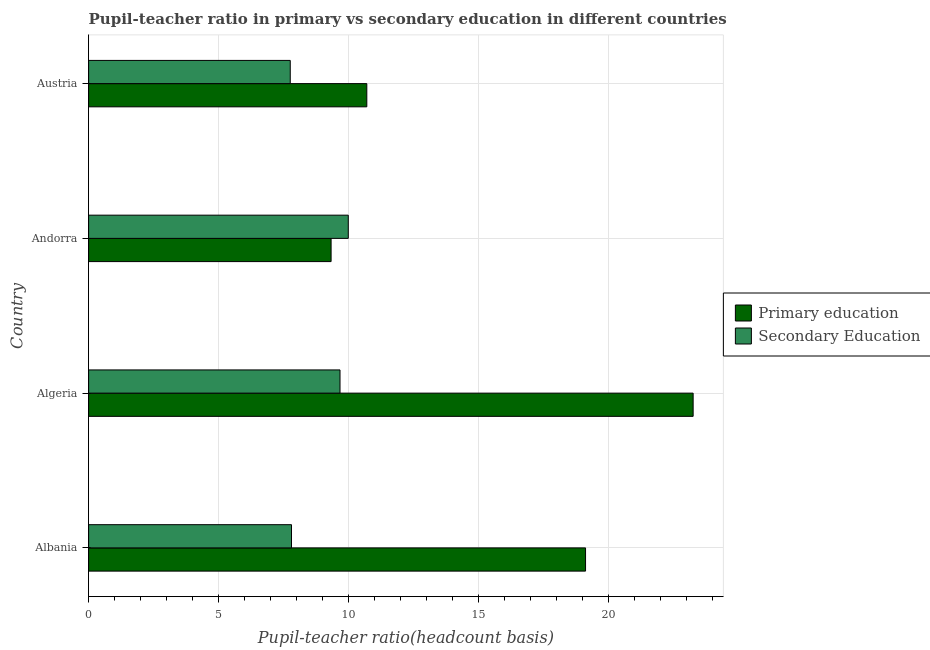How many different coloured bars are there?
Your answer should be very brief. 2. Are the number of bars on each tick of the Y-axis equal?
Keep it short and to the point. Yes. How many bars are there on the 3rd tick from the top?
Your answer should be compact. 2. How many bars are there on the 1st tick from the bottom?
Your answer should be very brief. 2. What is the label of the 3rd group of bars from the top?
Keep it short and to the point. Algeria. What is the pupil teacher ratio on secondary education in Andorra?
Give a very brief answer. 9.99. Across all countries, what is the maximum pupil teacher ratio on secondary education?
Your response must be concise. 9.99. Across all countries, what is the minimum pupil teacher ratio on secondary education?
Keep it short and to the point. 7.76. In which country was the pupil teacher ratio on secondary education maximum?
Ensure brevity in your answer.  Andorra. What is the total pupil-teacher ratio in primary education in the graph?
Offer a terse response. 62.42. What is the difference between the pupil-teacher ratio in primary education in Andorra and that in Austria?
Provide a short and direct response. -1.37. What is the difference between the pupil-teacher ratio in primary education in Andorra and the pupil teacher ratio on secondary education in Algeria?
Your response must be concise. -0.34. What is the average pupil-teacher ratio in primary education per country?
Make the answer very short. 15.6. What is the difference between the pupil teacher ratio on secondary education and pupil-teacher ratio in primary education in Andorra?
Keep it short and to the point. 0.66. What is the ratio of the pupil-teacher ratio in primary education in Albania to that in Algeria?
Give a very brief answer. 0.82. Is the pupil-teacher ratio in primary education in Algeria less than that in Austria?
Make the answer very short. No. What is the difference between the highest and the second highest pupil-teacher ratio in primary education?
Provide a succinct answer. 4.14. What is the difference between the highest and the lowest pupil teacher ratio on secondary education?
Offer a very short reply. 2.23. What does the 2nd bar from the bottom in Austria represents?
Offer a very short reply. Secondary Education. How many bars are there?
Ensure brevity in your answer.  8. Are all the bars in the graph horizontal?
Offer a terse response. Yes. How many countries are there in the graph?
Make the answer very short. 4. What is the difference between two consecutive major ticks on the X-axis?
Offer a terse response. 5. Are the values on the major ticks of X-axis written in scientific E-notation?
Your answer should be very brief. No. Does the graph contain grids?
Your answer should be compact. Yes. Where does the legend appear in the graph?
Your response must be concise. Center right. How are the legend labels stacked?
Give a very brief answer. Vertical. What is the title of the graph?
Offer a terse response. Pupil-teacher ratio in primary vs secondary education in different countries. Does "Male population" appear as one of the legend labels in the graph?
Offer a very short reply. No. What is the label or title of the X-axis?
Ensure brevity in your answer.  Pupil-teacher ratio(headcount basis). What is the Pupil-teacher ratio(headcount basis) in Primary education in Albania?
Make the answer very short. 19.12. What is the Pupil-teacher ratio(headcount basis) in Secondary Education in Albania?
Make the answer very short. 7.81. What is the Pupil-teacher ratio(headcount basis) of Primary education in Algeria?
Make the answer very short. 23.26. What is the Pupil-teacher ratio(headcount basis) in Secondary Education in Algeria?
Offer a very short reply. 9.67. What is the Pupil-teacher ratio(headcount basis) of Primary education in Andorra?
Provide a short and direct response. 9.33. What is the Pupil-teacher ratio(headcount basis) of Secondary Education in Andorra?
Your response must be concise. 9.99. What is the Pupil-teacher ratio(headcount basis) of Primary education in Austria?
Keep it short and to the point. 10.7. What is the Pupil-teacher ratio(headcount basis) in Secondary Education in Austria?
Offer a terse response. 7.76. Across all countries, what is the maximum Pupil-teacher ratio(headcount basis) in Primary education?
Keep it short and to the point. 23.26. Across all countries, what is the maximum Pupil-teacher ratio(headcount basis) in Secondary Education?
Ensure brevity in your answer.  9.99. Across all countries, what is the minimum Pupil-teacher ratio(headcount basis) of Primary education?
Your answer should be compact. 9.33. Across all countries, what is the minimum Pupil-teacher ratio(headcount basis) in Secondary Education?
Give a very brief answer. 7.76. What is the total Pupil-teacher ratio(headcount basis) of Primary education in the graph?
Offer a very short reply. 62.42. What is the total Pupil-teacher ratio(headcount basis) of Secondary Education in the graph?
Offer a terse response. 35.23. What is the difference between the Pupil-teacher ratio(headcount basis) of Primary education in Albania and that in Algeria?
Keep it short and to the point. -4.14. What is the difference between the Pupil-teacher ratio(headcount basis) in Secondary Education in Albania and that in Algeria?
Your answer should be very brief. -1.87. What is the difference between the Pupil-teacher ratio(headcount basis) in Primary education in Albania and that in Andorra?
Offer a terse response. 9.79. What is the difference between the Pupil-teacher ratio(headcount basis) of Secondary Education in Albania and that in Andorra?
Ensure brevity in your answer.  -2.19. What is the difference between the Pupil-teacher ratio(headcount basis) in Primary education in Albania and that in Austria?
Provide a short and direct response. 8.42. What is the difference between the Pupil-teacher ratio(headcount basis) of Secondary Education in Albania and that in Austria?
Your answer should be compact. 0.05. What is the difference between the Pupil-teacher ratio(headcount basis) in Primary education in Algeria and that in Andorra?
Make the answer very short. 13.93. What is the difference between the Pupil-teacher ratio(headcount basis) of Secondary Education in Algeria and that in Andorra?
Give a very brief answer. -0.32. What is the difference between the Pupil-teacher ratio(headcount basis) of Primary education in Algeria and that in Austria?
Your answer should be compact. 12.56. What is the difference between the Pupil-teacher ratio(headcount basis) of Secondary Education in Algeria and that in Austria?
Your answer should be very brief. 1.92. What is the difference between the Pupil-teacher ratio(headcount basis) of Primary education in Andorra and that in Austria?
Your response must be concise. -1.37. What is the difference between the Pupil-teacher ratio(headcount basis) of Secondary Education in Andorra and that in Austria?
Provide a succinct answer. 2.23. What is the difference between the Pupil-teacher ratio(headcount basis) of Primary education in Albania and the Pupil-teacher ratio(headcount basis) of Secondary Education in Algeria?
Provide a succinct answer. 9.45. What is the difference between the Pupil-teacher ratio(headcount basis) in Primary education in Albania and the Pupil-teacher ratio(headcount basis) in Secondary Education in Andorra?
Offer a terse response. 9.13. What is the difference between the Pupil-teacher ratio(headcount basis) in Primary education in Albania and the Pupil-teacher ratio(headcount basis) in Secondary Education in Austria?
Your answer should be very brief. 11.36. What is the difference between the Pupil-teacher ratio(headcount basis) of Primary education in Algeria and the Pupil-teacher ratio(headcount basis) of Secondary Education in Andorra?
Ensure brevity in your answer.  13.27. What is the difference between the Pupil-teacher ratio(headcount basis) in Primary education in Algeria and the Pupil-teacher ratio(headcount basis) in Secondary Education in Austria?
Give a very brief answer. 15.5. What is the difference between the Pupil-teacher ratio(headcount basis) in Primary education in Andorra and the Pupil-teacher ratio(headcount basis) in Secondary Education in Austria?
Your response must be concise. 1.57. What is the average Pupil-teacher ratio(headcount basis) in Primary education per country?
Offer a very short reply. 15.6. What is the average Pupil-teacher ratio(headcount basis) in Secondary Education per country?
Offer a terse response. 8.81. What is the difference between the Pupil-teacher ratio(headcount basis) in Primary education and Pupil-teacher ratio(headcount basis) in Secondary Education in Albania?
Ensure brevity in your answer.  11.31. What is the difference between the Pupil-teacher ratio(headcount basis) in Primary education and Pupil-teacher ratio(headcount basis) in Secondary Education in Algeria?
Offer a terse response. 13.59. What is the difference between the Pupil-teacher ratio(headcount basis) in Primary education and Pupil-teacher ratio(headcount basis) in Secondary Education in Andorra?
Make the answer very short. -0.66. What is the difference between the Pupil-teacher ratio(headcount basis) in Primary education and Pupil-teacher ratio(headcount basis) in Secondary Education in Austria?
Your answer should be very brief. 2.95. What is the ratio of the Pupil-teacher ratio(headcount basis) of Primary education in Albania to that in Algeria?
Keep it short and to the point. 0.82. What is the ratio of the Pupil-teacher ratio(headcount basis) of Secondary Education in Albania to that in Algeria?
Offer a terse response. 0.81. What is the ratio of the Pupil-teacher ratio(headcount basis) of Primary education in Albania to that in Andorra?
Keep it short and to the point. 2.05. What is the ratio of the Pupil-teacher ratio(headcount basis) in Secondary Education in Albania to that in Andorra?
Your response must be concise. 0.78. What is the ratio of the Pupil-teacher ratio(headcount basis) in Primary education in Albania to that in Austria?
Offer a terse response. 1.79. What is the ratio of the Pupil-teacher ratio(headcount basis) of Primary education in Algeria to that in Andorra?
Offer a terse response. 2.49. What is the ratio of the Pupil-teacher ratio(headcount basis) in Secondary Education in Algeria to that in Andorra?
Make the answer very short. 0.97. What is the ratio of the Pupil-teacher ratio(headcount basis) in Primary education in Algeria to that in Austria?
Your answer should be very brief. 2.17. What is the ratio of the Pupil-teacher ratio(headcount basis) in Secondary Education in Algeria to that in Austria?
Offer a terse response. 1.25. What is the ratio of the Pupil-teacher ratio(headcount basis) of Primary education in Andorra to that in Austria?
Keep it short and to the point. 0.87. What is the ratio of the Pupil-teacher ratio(headcount basis) of Secondary Education in Andorra to that in Austria?
Your answer should be very brief. 1.29. What is the difference between the highest and the second highest Pupil-teacher ratio(headcount basis) of Primary education?
Provide a short and direct response. 4.14. What is the difference between the highest and the second highest Pupil-teacher ratio(headcount basis) in Secondary Education?
Offer a very short reply. 0.32. What is the difference between the highest and the lowest Pupil-teacher ratio(headcount basis) in Primary education?
Your response must be concise. 13.93. What is the difference between the highest and the lowest Pupil-teacher ratio(headcount basis) of Secondary Education?
Your answer should be very brief. 2.23. 